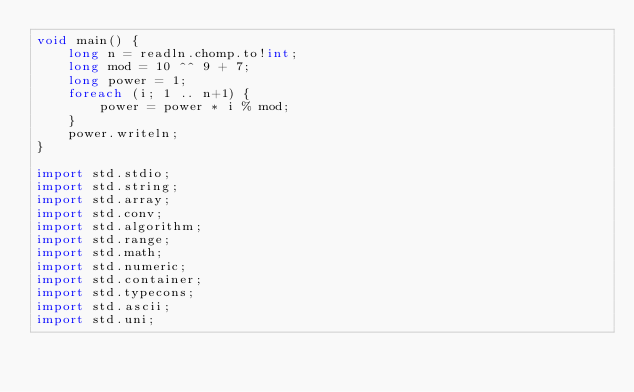Convert code to text. <code><loc_0><loc_0><loc_500><loc_500><_D_>void main() {
    long n = readln.chomp.to!int;
    long mod = 10 ^^ 9 + 7;
    long power = 1;
    foreach (i; 1 .. n+1) {
        power = power * i % mod;
    }
    power.writeln;
}

import std.stdio;
import std.string;
import std.array;
import std.conv;
import std.algorithm;
import std.range;
import std.math;
import std.numeric;
import std.container;
import std.typecons;
import std.ascii;
import std.uni;</code> 